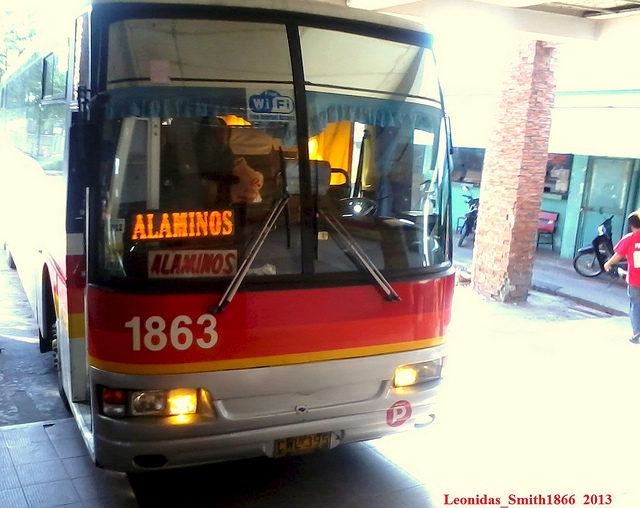Can you tell me more about the destination displayed on the bus? The destination shown on the bus is Alaminos. Alaminos is possibly a city or region that this bus is servicing. Passengers might be heading there for various reasons, such as tourism, business, or visiting family and friends. It's common for buses to prominently display their destinations so passengers can easily identify the correct service for their journey. 